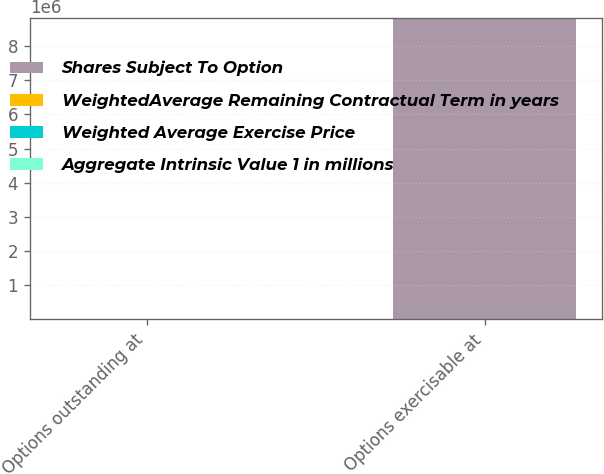Convert chart. <chart><loc_0><loc_0><loc_500><loc_500><stacked_bar_chart><ecel><fcel>Options outstanding at<fcel>Options exercisable at<nl><fcel>Shares Subject To Option<fcel>15.08<fcel>8.83739e+06<nl><fcel>WeightedAverage Remaining Contractual Term in years<fcel>14.84<fcel>15.08<nl><fcel>Weighted Average Exercise Price<fcel>6.4<fcel>4.7<nl><fcel>Aggregate Intrinsic Value 1 in millions<fcel>75.2<fcel>38.2<nl></chart> 